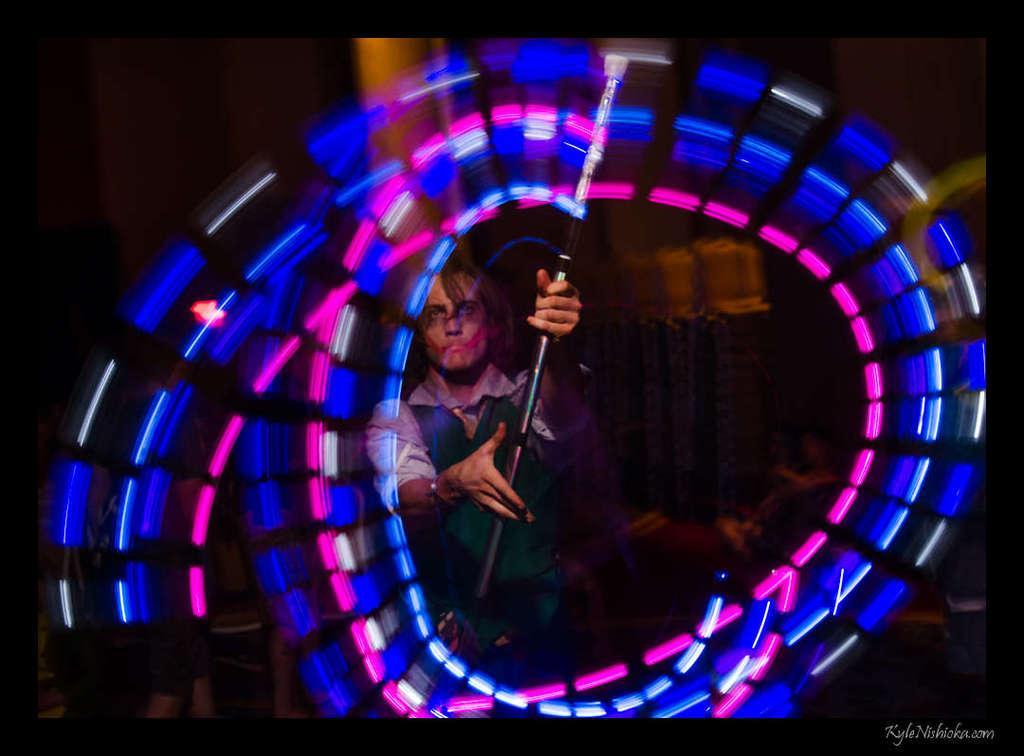Can you describe this image briefly? In the foreground of this picture, there is a person standing and holding a stick like an object through which lights are emitted and we can see a circular motion of lights raised by the stick. 